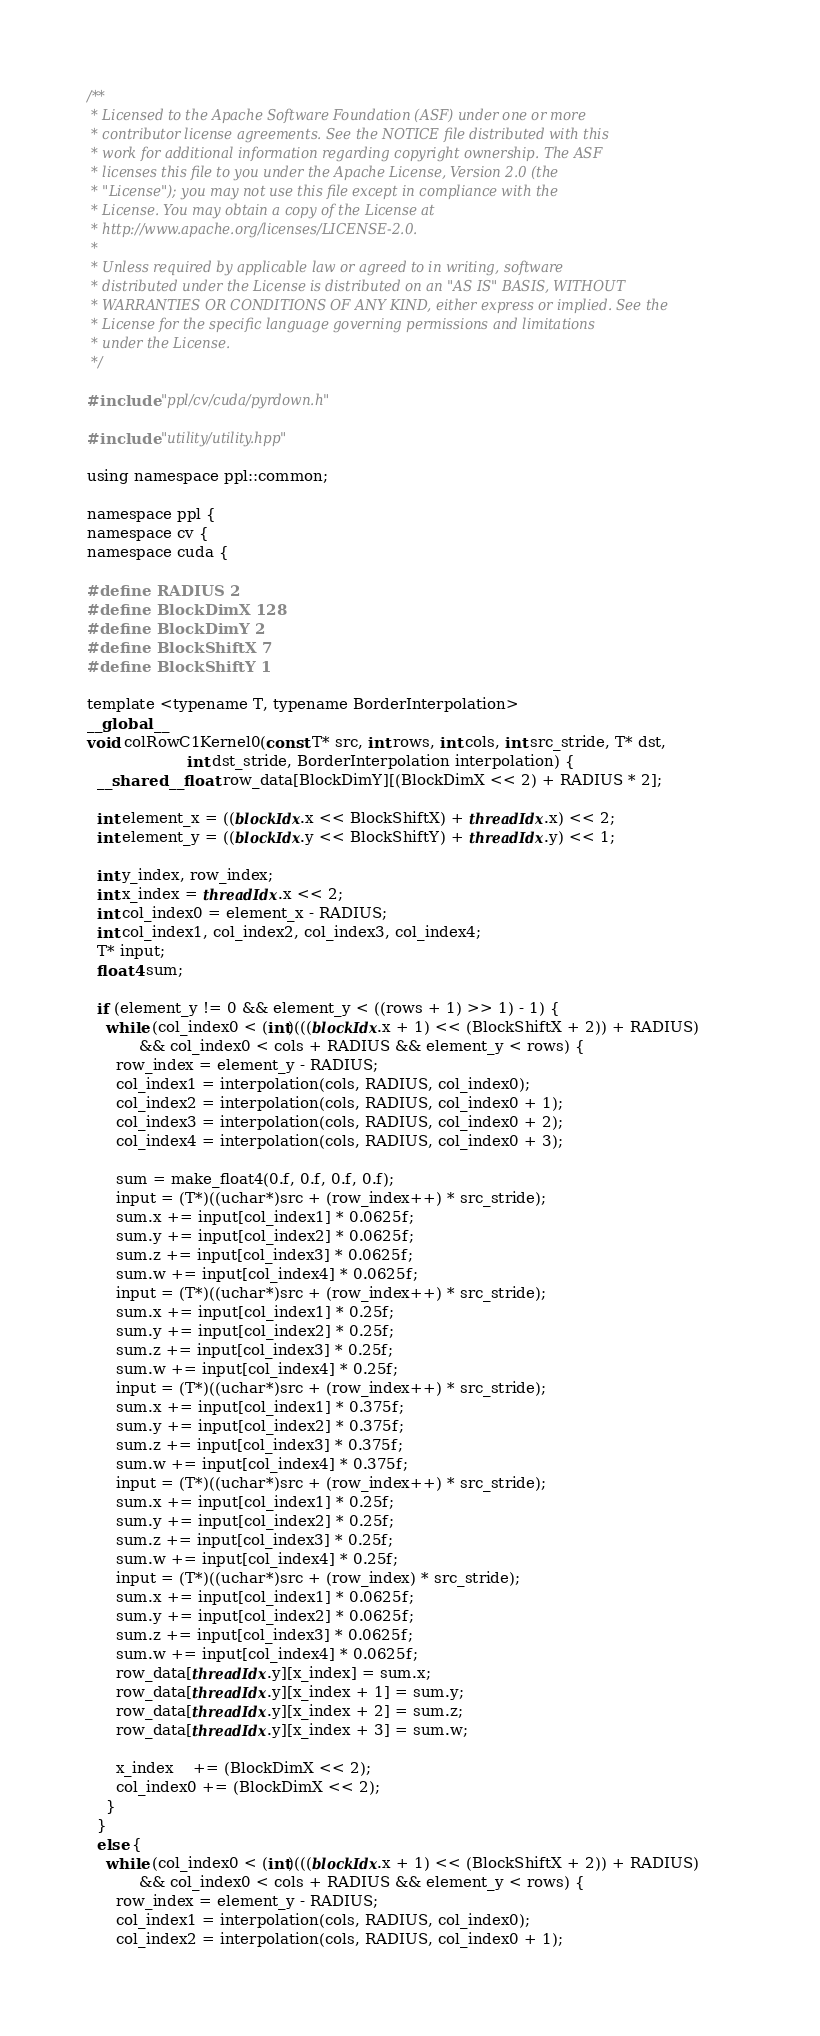<code> <loc_0><loc_0><loc_500><loc_500><_Cuda_>/**
 * Licensed to the Apache Software Foundation (ASF) under one or more
 * contributor license agreements. See the NOTICE file distributed with this
 * work for additional information regarding copyright ownership. The ASF
 * licenses this file to you under the Apache License, Version 2.0 (the
 * "License"); you may not use this file except in compliance with the
 * License. You may obtain a copy of the License at
 * http://www.apache.org/licenses/LICENSE-2.0.
 *
 * Unless required by applicable law or agreed to in writing, software
 * distributed under the License is distributed on an "AS IS" BASIS, WITHOUT
 * WARRANTIES OR CONDITIONS OF ANY KIND, either express or implied. See the
 * License for the specific language governing permissions and limitations
 * under the License.
 */

#include "ppl/cv/cuda/pyrdown.h"

#include "utility/utility.hpp"

using namespace ppl::common;

namespace ppl {
namespace cv {
namespace cuda {

#define RADIUS 2
#define BlockDimX 128
#define BlockDimY 2
#define BlockShiftX 7
#define BlockShiftY 1

template <typename T, typename BorderInterpolation>
__global__
void colRowC1Kernel0(const T* src, int rows, int cols, int src_stride, T* dst,
                     int dst_stride, BorderInterpolation interpolation) {
  __shared__ float row_data[BlockDimY][(BlockDimX << 2) + RADIUS * 2];

  int element_x = ((blockIdx.x << BlockShiftX) + threadIdx.x) << 2;
  int element_y = ((blockIdx.y << BlockShiftY) + threadIdx.y) << 1;

  int y_index, row_index;
  int x_index = threadIdx.x << 2;
  int col_index0 = element_x - RADIUS;
  int col_index1, col_index2, col_index3, col_index4;
  T* input;
  float4 sum;

  if (element_y != 0 && element_y < ((rows + 1) >> 1) - 1) {
    while (col_index0 < (int)(((blockIdx.x + 1) << (BlockShiftX + 2)) + RADIUS)
           && col_index0 < cols + RADIUS && element_y < rows) {
      row_index = element_y - RADIUS;
      col_index1 = interpolation(cols, RADIUS, col_index0);
      col_index2 = interpolation(cols, RADIUS, col_index0 + 1);
      col_index3 = interpolation(cols, RADIUS, col_index0 + 2);
      col_index4 = interpolation(cols, RADIUS, col_index0 + 3);

      sum = make_float4(0.f, 0.f, 0.f, 0.f);
      input = (T*)((uchar*)src + (row_index++) * src_stride);
      sum.x += input[col_index1] * 0.0625f;
      sum.y += input[col_index2] * 0.0625f;
      sum.z += input[col_index3] * 0.0625f;
      sum.w += input[col_index4] * 0.0625f;
      input = (T*)((uchar*)src + (row_index++) * src_stride);
      sum.x += input[col_index1] * 0.25f;
      sum.y += input[col_index2] * 0.25f;
      sum.z += input[col_index3] * 0.25f;
      sum.w += input[col_index4] * 0.25f;
      input = (T*)((uchar*)src + (row_index++) * src_stride);
      sum.x += input[col_index1] * 0.375f;
      sum.y += input[col_index2] * 0.375f;
      sum.z += input[col_index3] * 0.375f;
      sum.w += input[col_index4] * 0.375f;
      input = (T*)((uchar*)src + (row_index++) * src_stride);
      sum.x += input[col_index1] * 0.25f;
      sum.y += input[col_index2] * 0.25f;
      sum.z += input[col_index3] * 0.25f;
      sum.w += input[col_index4] * 0.25f;
      input = (T*)((uchar*)src + (row_index) * src_stride);
      sum.x += input[col_index1] * 0.0625f;
      sum.y += input[col_index2] * 0.0625f;
      sum.z += input[col_index3] * 0.0625f;
      sum.w += input[col_index4] * 0.0625f;
      row_data[threadIdx.y][x_index] = sum.x;
      row_data[threadIdx.y][x_index + 1] = sum.y;
      row_data[threadIdx.y][x_index + 2] = sum.z;
      row_data[threadIdx.y][x_index + 3] = sum.w;

      x_index    += (BlockDimX << 2);
      col_index0 += (BlockDimX << 2);
    }
  }
  else {
    while (col_index0 < (int)(((blockIdx.x + 1) << (BlockShiftX + 2)) + RADIUS)
           && col_index0 < cols + RADIUS && element_y < rows) {
      row_index = element_y - RADIUS;
      col_index1 = interpolation(cols, RADIUS, col_index0);
      col_index2 = interpolation(cols, RADIUS, col_index0 + 1);</code> 